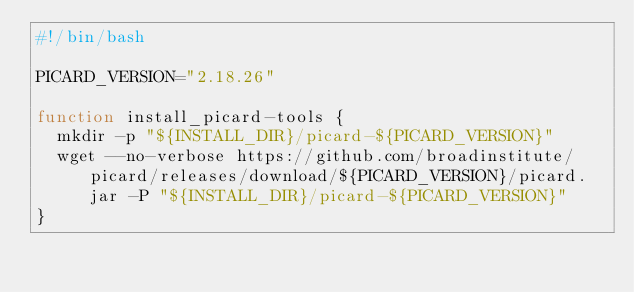Convert code to text. <code><loc_0><loc_0><loc_500><loc_500><_Bash_>#!/bin/bash

PICARD_VERSION="2.18.26"

function install_picard-tools {
  mkdir -p "${INSTALL_DIR}/picard-${PICARD_VERSION}"
  wget --no-verbose https://github.com/broadinstitute/picard/releases/download/${PICARD_VERSION}/picard.jar -P "${INSTALL_DIR}/picard-${PICARD_VERSION}"
}
</code> 